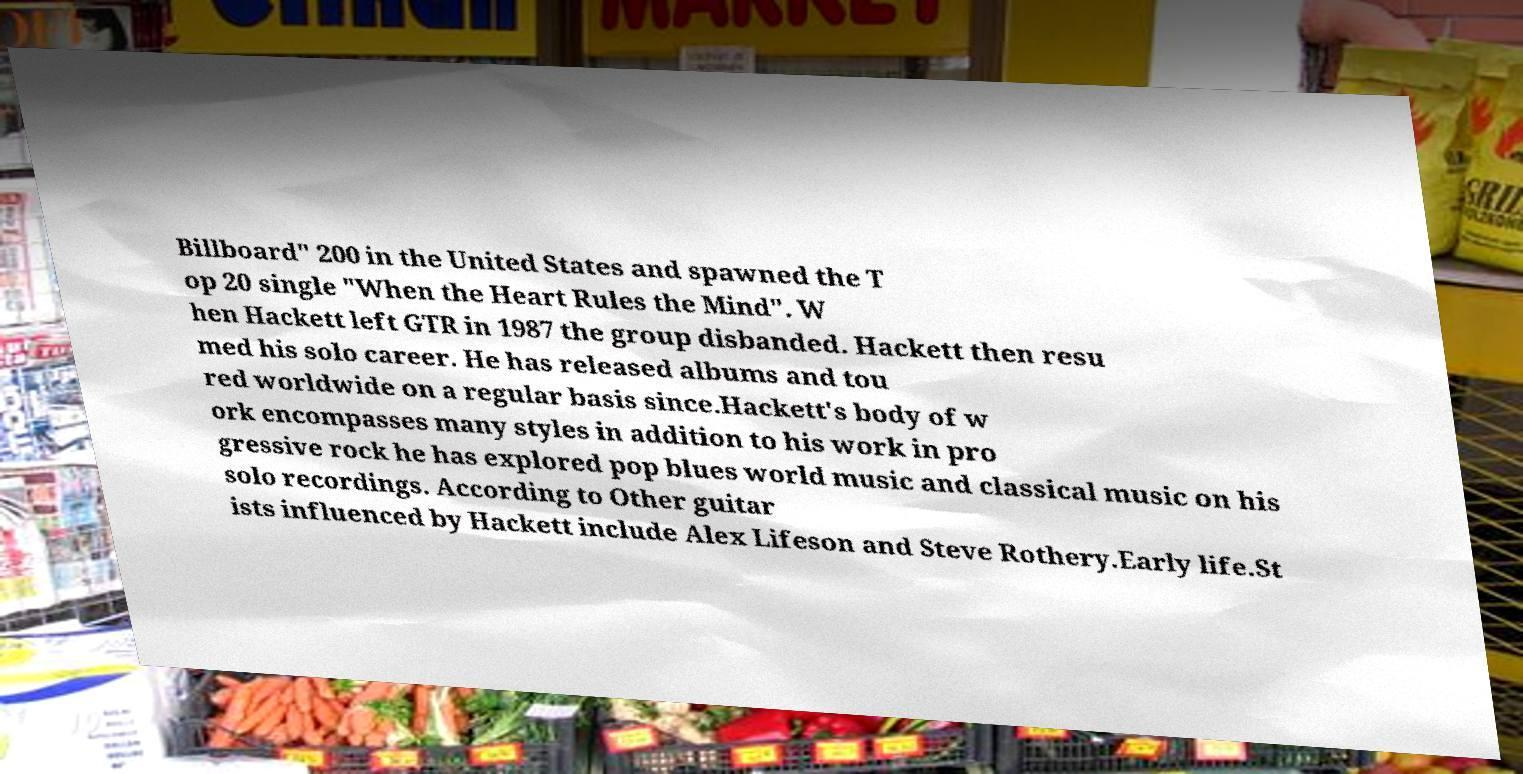Can you accurately transcribe the text from the provided image for me? Billboard" 200 in the United States and spawned the T op 20 single "When the Heart Rules the Mind". W hen Hackett left GTR in 1987 the group disbanded. Hackett then resu med his solo career. He has released albums and tou red worldwide on a regular basis since.Hackett's body of w ork encompasses many styles in addition to his work in pro gressive rock he has explored pop blues world music and classical music on his solo recordings. According to Other guitar ists influenced by Hackett include Alex Lifeson and Steve Rothery.Early life.St 